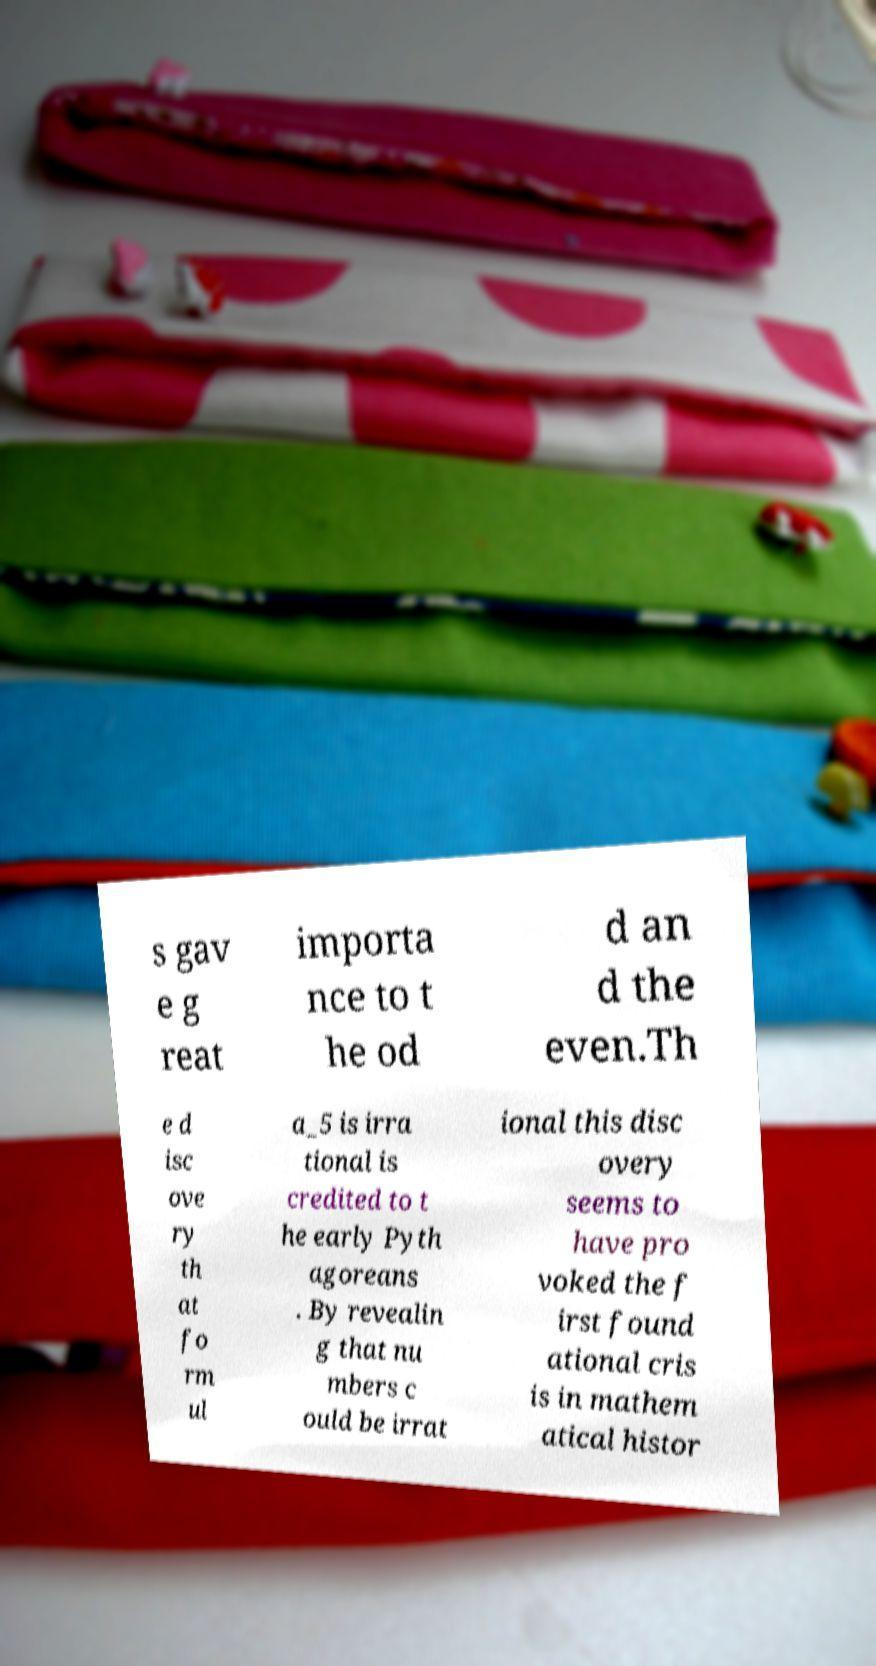There's text embedded in this image that I need extracted. Can you transcribe it verbatim? s gav e g reat importa nce to t he od d an d the even.Th e d isc ove ry th at fo rm ul a_5 is irra tional is credited to t he early Pyth agoreans . By revealin g that nu mbers c ould be irrat ional this disc overy seems to have pro voked the f irst found ational cris is in mathem atical histor 